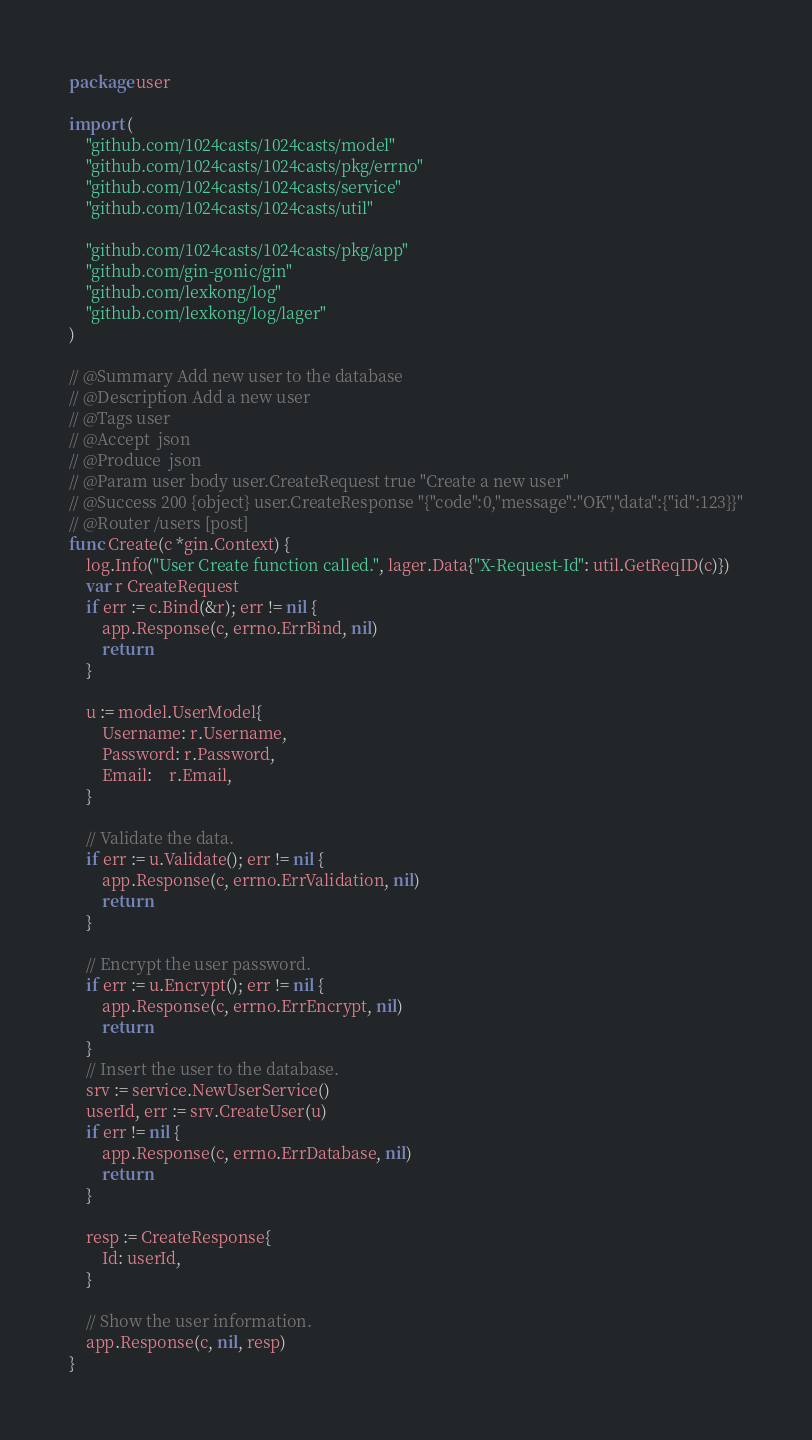Convert code to text. <code><loc_0><loc_0><loc_500><loc_500><_Go_>package user

import (
	"github.com/1024casts/1024casts/model"
	"github.com/1024casts/1024casts/pkg/errno"
	"github.com/1024casts/1024casts/service"
	"github.com/1024casts/1024casts/util"

	"github.com/1024casts/1024casts/pkg/app"
	"github.com/gin-gonic/gin"
	"github.com/lexkong/log"
	"github.com/lexkong/log/lager"
)

// @Summary Add new user to the database
// @Description Add a new user
// @Tags user
// @Accept  json
// @Produce  json
// @Param user body user.CreateRequest true "Create a new user"
// @Success 200 {object} user.CreateResponse "{"code":0,"message":"OK","data":{"id":123}}"
// @Router /users [post]
func Create(c *gin.Context) {
	log.Info("User Create function called.", lager.Data{"X-Request-Id": util.GetReqID(c)})
	var r CreateRequest
	if err := c.Bind(&r); err != nil {
		app.Response(c, errno.ErrBind, nil)
		return
	}

	u := model.UserModel{
		Username: r.Username,
		Password: r.Password,
		Email:    r.Email,
	}

	// Validate the data.
	if err := u.Validate(); err != nil {
		app.Response(c, errno.ErrValidation, nil)
		return
	}

	// Encrypt the user password.
	if err := u.Encrypt(); err != nil {
		app.Response(c, errno.ErrEncrypt, nil)
		return
	}
	// Insert the user to the database.
	srv := service.NewUserService()
	userId, err := srv.CreateUser(u)
	if err != nil {
		app.Response(c, errno.ErrDatabase, nil)
		return
	}

	resp := CreateResponse{
		Id: userId,
	}

	// Show the user information.
	app.Response(c, nil, resp)
}
</code> 